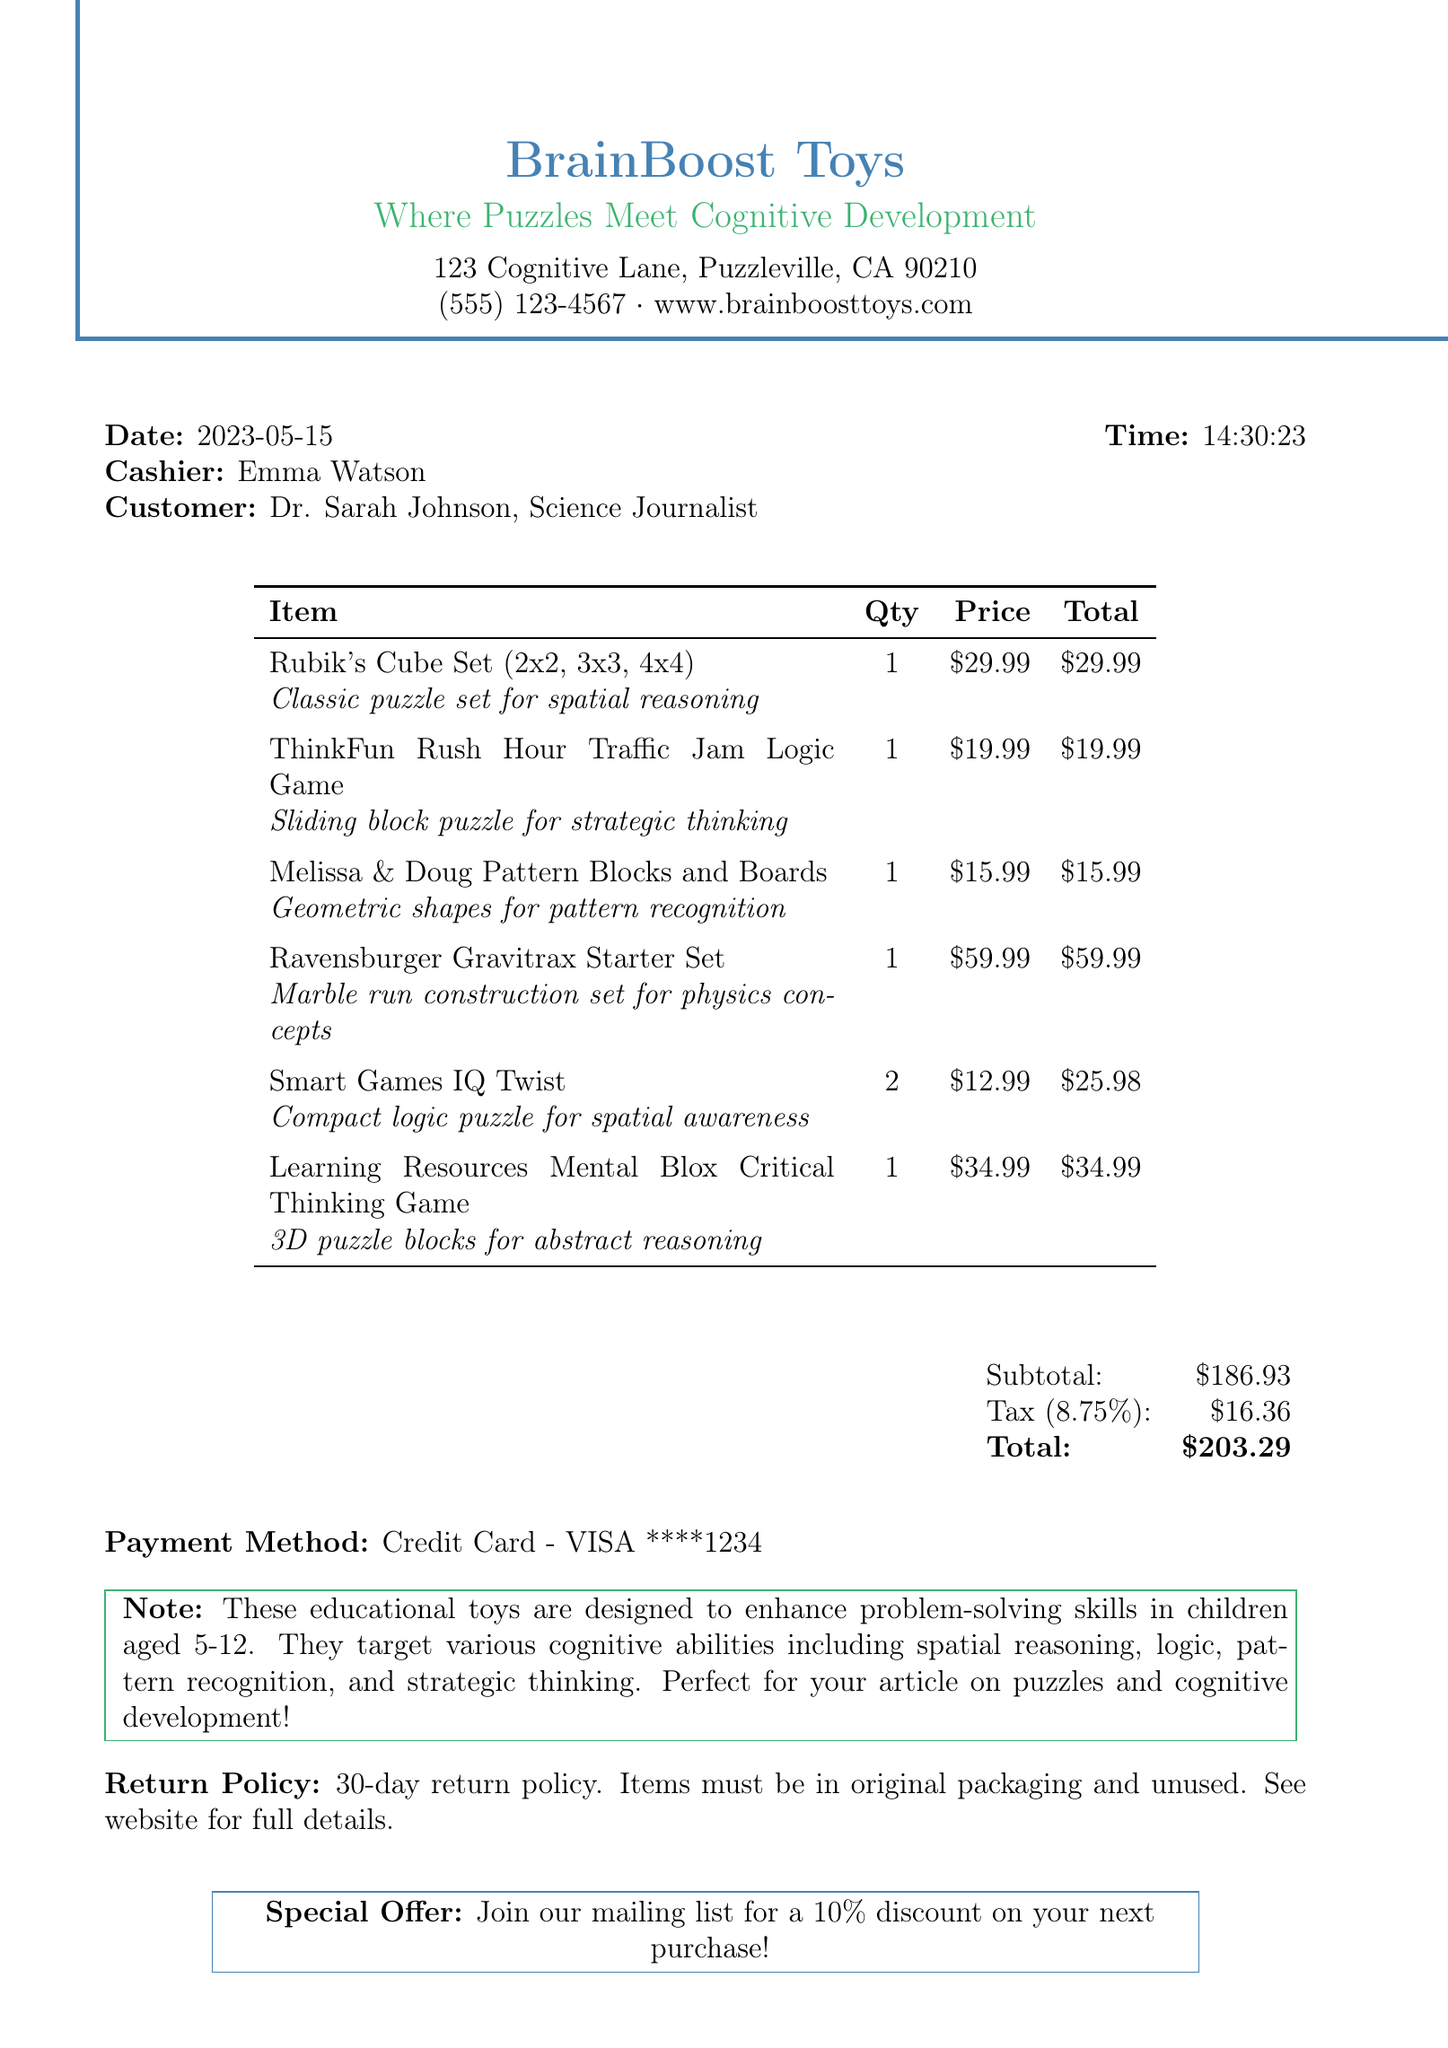What is the store name? The store name is located at the top of the receipt.
Answer: BrainBoost Toys Who is the cashier? The cashier's name is listed near the date and time.
Answer: Emma Watson What is the total amount paid? The total amount is calculated as the subtotal plus tax, found at the bottom of the receipt.
Answer: $203.29 How many Smart Games IQ Twist were purchased? The quantity for Smart Games IQ Twist is specified in the item list.
Answer: 2 What is the return policy duration? The return policy duration is mentioned in the notes section.
Answer: 30-day What is the main target age for the educational toys? The target age is stated in the note about the toys designed for children.
Answer: 5-12 What type of game is the ThinkFun Rush Hour Traffic Jam? The description of the item specifies its type.
Answer: Logic Game Which payment method was used? The payment method is specified toward the end of the receipt.
Answer: Credit Card - VISA ****1234 What is the subtotal before tax? The subtotal is provided in the financial summary section of the receipt.
Answer: $186.93 